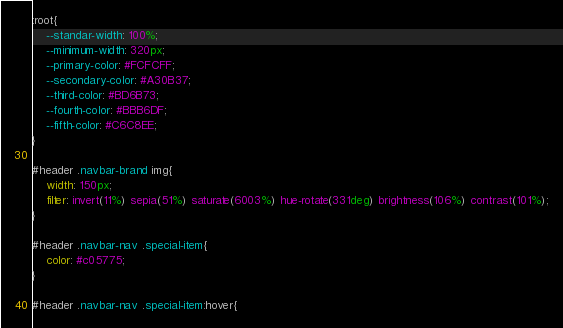Convert code to text. <code><loc_0><loc_0><loc_500><loc_500><_CSS_>:root{
    --standar-width: 100%;
    --minimum-width: 320px;
    --primary-color: #FCFCFF;
    --secondary-color: #A30B37;
    --third-color: #BD6B73;
    --fourth-color: #BBB6DF;
    --fifth-color: #C6C8EE;
}

#header .navbar-brand img{
    width: 150px;
    filter: invert(11%) sepia(51%) saturate(6003%) hue-rotate(331deg) brightness(106%) contrast(101%);
}

#header .navbar-nav .special-item{
    color: #c05775;
}

#header .navbar-nav .special-item:hover{</code> 